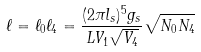Convert formula to latex. <formula><loc_0><loc_0><loc_500><loc_500>\ell = \ell _ { 0 } \ell _ { 4 } = \frac { ( 2 \pi l _ { s } ) ^ { 5 } g _ { s } } { L V _ { 1 } \sqrt { V _ { 4 } } } \sqrt { N _ { 0 } N _ { 4 } }</formula> 